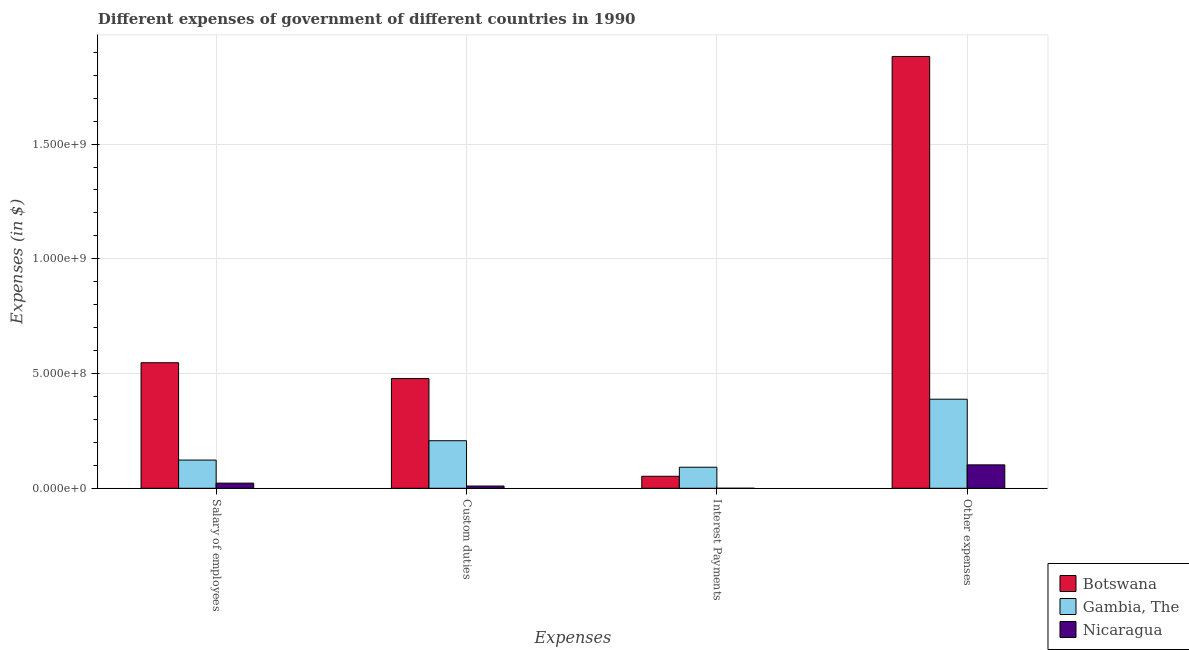How many different coloured bars are there?
Make the answer very short. 3. How many groups of bars are there?
Your response must be concise. 4. How many bars are there on the 1st tick from the left?
Provide a short and direct response. 3. What is the label of the 4th group of bars from the left?
Your answer should be compact. Other expenses. What is the amount spent on interest payments in Gambia, The?
Offer a very short reply. 9.17e+07. Across all countries, what is the maximum amount spent on salary of employees?
Give a very brief answer. 5.47e+08. Across all countries, what is the minimum amount spent on interest payments?
Keep it short and to the point. 8000. In which country was the amount spent on salary of employees maximum?
Offer a very short reply. Botswana. In which country was the amount spent on other expenses minimum?
Give a very brief answer. Nicaragua. What is the total amount spent on other expenses in the graph?
Ensure brevity in your answer.  2.37e+09. What is the difference between the amount spent on interest payments in Botswana and that in Nicaragua?
Your response must be concise. 5.23e+07. What is the difference between the amount spent on salary of employees in Nicaragua and the amount spent on interest payments in Botswana?
Offer a terse response. -2.99e+07. What is the average amount spent on other expenses per country?
Your response must be concise. 7.91e+08. What is the difference between the amount spent on salary of employees and amount spent on interest payments in Botswana?
Your answer should be very brief. 4.95e+08. What is the ratio of the amount spent on salary of employees in Nicaragua to that in Gambia, The?
Provide a short and direct response. 0.18. Is the difference between the amount spent on other expenses in Botswana and Nicaragua greater than the difference between the amount spent on custom duties in Botswana and Nicaragua?
Your answer should be very brief. Yes. What is the difference between the highest and the second highest amount spent on other expenses?
Make the answer very short. 1.49e+09. What is the difference between the highest and the lowest amount spent on custom duties?
Ensure brevity in your answer.  4.68e+08. In how many countries, is the amount spent on other expenses greater than the average amount spent on other expenses taken over all countries?
Your answer should be compact. 1. Is it the case that in every country, the sum of the amount spent on interest payments and amount spent on custom duties is greater than the sum of amount spent on other expenses and amount spent on salary of employees?
Give a very brief answer. No. What does the 1st bar from the left in Other expenses represents?
Offer a terse response. Botswana. What does the 3rd bar from the right in Other expenses represents?
Make the answer very short. Botswana. Is it the case that in every country, the sum of the amount spent on salary of employees and amount spent on custom duties is greater than the amount spent on interest payments?
Keep it short and to the point. Yes. Are all the bars in the graph horizontal?
Keep it short and to the point. No. What is the difference between two consecutive major ticks on the Y-axis?
Your response must be concise. 5.00e+08. Does the graph contain grids?
Your answer should be compact. Yes. How are the legend labels stacked?
Your answer should be very brief. Vertical. What is the title of the graph?
Provide a succinct answer. Different expenses of government of different countries in 1990. Does "East Asia (all income levels)" appear as one of the legend labels in the graph?
Your answer should be very brief. No. What is the label or title of the X-axis?
Offer a terse response. Expenses. What is the label or title of the Y-axis?
Provide a short and direct response. Expenses (in $). What is the Expenses (in $) in Botswana in Salary of employees?
Your answer should be very brief. 5.47e+08. What is the Expenses (in $) in Gambia, The in Salary of employees?
Ensure brevity in your answer.  1.23e+08. What is the Expenses (in $) in Nicaragua in Salary of employees?
Keep it short and to the point. 2.24e+07. What is the Expenses (in $) of Botswana in Custom duties?
Make the answer very short. 4.78e+08. What is the Expenses (in $) in Gambia, The in Custom duties?
Give a very brief answer. 2.07e+08. What is the Expenses (in $) of Nicaragua in Custom duties?
Your answer should be compact. 9.75e+06. What is the Expenses (in $) of Botswana in Interest Payments?
Offer a very short reply. 5.23e+07. What is the Expenses (in $) of Gambia, The in Interest Payments?
Your response must be concise. 9.17e+07. What is the Expenses (in $) of Nicaragua in Interest Payments?
Offer a terse response. 8000. What is the Expenses (in $) of Botswana in Other expenses?
Make the answer very short. 1.88e+09. What is the Expenses (in $) in Gambia, The in Other expenses?
Keep it short and to the point. 3.88e+08. What is the Expenses (in $) in Nicaragua in Other expenses?
Keep it short and to the point. 1.02e+08. Across all Expenses, what is the maximum Expenses (in $) of Botswana?
Make the answer very short. 1.88e+09. Across all Expenses, what is the maximum Expenses (in $) of Gambia, The?
Give a very brief answer. 3.88e+08. Across all Expenses, what is the maximum Expenses (in $) in Nicaragua?
Give a very brief answer. 1.02e+08. Across all Expenses, what is the minimum Expenses (in $) in Botswana?
Give a very brief answer. 5.23e+07. Across all Expenses, what is the minimum Expenses (in $) in Gambia, The?
Your answer should be very brief. 9.17e+07. Across all Expenses, what is the minimum Expenses (in $) of Nicaragua?
Offer a very short reply. 8000. What is the total Expenses (in $) in Botswana in the graph?
Make the answer very short. 2.96e+09. What is the total Expenses (in $) in Gambia, The in the graph?
Provide a short and direct response. 8.10e+08. What is the total Expenses (in $) in Nicaragua in the graph?
Offer a very short reply. 1.34e+08. What is the difference between the Expenses (in $) in Botswana in Salary of employees and that in Custom duties?
Provide a short and direct response. 6.89e+07. What is the difference between the Expenses (in $) of Gambia, The in Salary of employees and that in Custom duties?
Your answer should be compact. -8.43e+07. What is the difference between the Expenses (in $) of Nicaragua in Salary of employees and that in Custom duties?
Your response must be concise. 1.27e+07. What is the difference between the Expenses (in $) in Botswana in Salary of employees and that in Interest Payments?
Your answer should be compact. 4.95e+08. What is the difference between the Expenses (in $) in Gambia, The in Salary of employees and that in Interest Payments?
Make the answer very short. 3.12e+07. What is the difference between the Expenses (in $) in Nicaragua in Salary of employees and that in Interest Payments?
Your response must be concise. 2.24e+07. What is the difference between the Expenses (in $) in Botswana in Salary of employees and that in Other expenses?
Make the answer very short. -1.33e+09. What is the difference between the Expenses (in $) in Gambia, The in Salary of employees and that in Other expenses?
Your answer should be very brief. -2.65e+08. What is the difference between the Expenses (in $) in Nicaragua in Salary of employees and that in Other expenses?
Offer a terse response. -7.96e+07. What is the difference between the Expenses (in $) in Botswana in Custom duties and that in Interest Payments?
Provide a succinct answer. 4.26e+08. What is the difference between the Expenses (in $) in Gambia, The in Custom duties and that in Interest Payments?
Keep it short and to the point. 1.16e+08. What is the difference between the Expenses (in $) of Nicaragua in Custom duties and that in Interest Payments?
Keep it short and to the point. 9.74e+06. What is the difference between the Expenses (in $) of Botswana in Custom duties and that in Other expenses?
Provide a succinct answer. -1.40e+09. What is the difference between the Expenses (in $) of Gambia, The in Custom duties and that in Other expenses?
Provide a succinct answer. -1.81e+08. What is the difference between the Expenses (in $) in Nicaragua in Custom duties and that in Other expenses?
Offer a terse response. -9.23e+07. What is the difference between the Expenses (in $) in Botswana in Interest Payments and that in Other expenses?
Keep it short and to the point. -1.83e+09. What is the difference between the Expenses (in $) in Gambia, The in Interest Payments and that in Other expenses?
Give a very brief answer. -2.96e+08. What is the difference between the Expenses (in $) of Nicaragua in Interest Payments and that in Other expenses?
Give a very brief answer. -1.02e+08. What is the difference between the Expenses (in $) of Botswana in Salary of employees and the Expenses (in $) of Gambia, The in Custom duties?
Ensure brevity in your answer.  3.40e+08. What is the difference between the Expenses (in $) of Botswana in Salary of employees and the Expenses (in $) of Nicaragua in Custom duties?
Keep it short and to the point. 5.37e+08. What is the difference between the Expenses (in $) in Gambia, The in Salary of employees and the Expenses (in $) in Nicaragua in Custom duties?
Provide a short and direct response. 1.13e+08. What is the difference between the Expenses (in $) in Botswana in Salary of employees and the Expenses (in $) in Gambia, The in Interest Payments?
Provide a short and direct response. 4.55e+08. What is the difference between the Expenses (in $) in Botswana in Salary of employees and the Expenses (in $) in Nicaragua in Interest Payments?
Keep it short and to the point. 5.47e+08. What is the difference between the Expenses (in $) of Gambia, The in Salary of employees and the Expenses (in $) of Nicaragua in Interest Payments?
Offer a terse response. 1.23e+08. What is the difference between the Expenses (in $) in Botswana in Salary of employees and the Expenses (in $) in Gambia, The in Other expenses?
Provide a succinct answer. 1.59e+08. What is the difference between the Expenses (in $) in Botswana in Salary of employees and the Expenses (in $) in Nicaragua in Other expenses?
Your response must be concise. 4.45e+08. What is the difference between the Expenses (in $) in Gambia, The in Salary of employees and the Expenses (in $) in Nicaragua in Other expenses?
Make the answer very short. 2.09e+07. What is the difference between the Expenses (in $) of Botswana in Custom duties and the Expenses (in $) of Gambia, The in Interest Payments?
Provide a succinct answer. 3.86e+08. What is the difference between the Expenses (in $) of Botswana in Custom duties and the Expenses (in $) of Nicaragua in Interest Payments?
Keep it short and to the point. 4.78e+08. What is the difference between the Expenses (in $) of Gambia, The in Custom duties and the Expenses (in $) of Nicaragua in Interest Payments?
Offer a terse response. 2.07e+08. What is the difference between the Expenses (in $) of Botswana in Custom duties and the Expenses (in $) of Gambia, The in Other expenses?
Your answer should be very brief. 9.00e+07. What is the difference between the Expenses (in $) of Botswana in Custom duties and the Expenses (in $) of Nicaragua in Other expenses?
Make the answer very short. 3.76e+08. What is the difference between the Expenses (in $) of Gambia, The in Custom duties and the Expenses (in $) of Nicaragua in Other expenses?
Offer a very short reply. 1.05e+08. What is the difference between the Expenses (in $) of Botswana in Interest Payments and the Expenses (in $) of Gambia, The in Other expenses?
Give a very brief answer. -3.36e+08. What is the difference between the Expenses (in $) of Botswana in Interest Payments and the Expenses (in $) of Nicaragua in Other expenses?
Your answer should be compact. -4.97e+07. What is the difference between the Expenses (in $) in Gambia, The in Interest Payments and the Expenses (in $) in Nicaragua in Other expenses?
Your answer should be very brief. -1.03e+07. What is the average Expenses (in $) in Botswana per Expenses?
Make the answer very short. 7.40e+08. What is the average Expenses (in $) of Gambia, The per Expenses?
Keep it short and to the point. 2.03e+08. What is the average Expenses (in $) in Nicaragua per Expenses?
Make the answer very short. 3.36e+07. What is the difference between the Expenses (in $) of Botswana and Expenses (in $) of Gambia, The in Salary of employees?
Your answer should be compact. 4.24e+08. What is the difference between the Expenses (in $) in Botswana and Expenses (in $) in Nicaragua in Salary of employees?
Your answer should be compact. 5.25e+08. What is the difference between the Expenses (in $) in Gambia, The and Expenses (in $) in Nicaragua in Salary of employees?
Make the answer very short. 1.00e+08. What is the difference between the Expenses (in $) in Botswana and Expenses (in $) in Gambia, The in Custom duties?
Offer a terse response. 2.71e+08. What is the difference between the Expenses (in $) of Botswana and Expenses (in $) of Nicaragua in Custom duties?
Offer a very short reply. 4.68e+08. What is the difference between the Expenses (in $) in Gambia, The and Expenses (in $) in Nicaragua in Custom duties?
Provide a succinct answer. 1.97e+08. What is the difference between the Expenses (in $) of Botswana and Expenses (in $) of Gambia, The in Interest Payments?
Offer a terse response. -3.94e+07. What is the difference between the Expenses (in $) of Botswana and Expenses (in $) of Nicaragua in Interest Payments?
Keep it short and to the point. 5.23e+07. What is the difference between the Expenses (in $) in Gambia, The and Expenses (in $) in Nicaragua in Interest Payments?
Your response must be concise. 9.17e+07. What is the difference between the Expenses (in $) of Botswana and Expenses (in $) of Gambia, The in Other expenses?
Your answer should be very brief. 1.49e+09. What is the difference between the Expenses (in $) in Botswana and Expenses (in $) in Nicaragua in Other expenses?
Your response must be concise. 1.78e+09. What is the difference between the Expenses (in $) in Gambia, The and Expenses (in $) in Nicaragua in Other expenses?
Your response must be concise. 2.86e+08. What is the ratio of the Expenses (in $) in Botswana in Salary of employees to that in Custom duties?
Give a very brief answer. 1.14. What is the ratio of the Expenses (in $) in Gambia, The in Salary of employees to that in Custom duties?
Give a very brief answer. 0.59. What is the ratio of the Expenses (in $) in Nicaragua in Salary of employees to that in Custom duties?
Give a very brief answer. 2.3. What is the ratio of the Expenses (in $) in Botswana in Salary of employees to that in Interest Payments?
Ensure brevity in your answer.  10.46. What is the ratio of the Expenses (in $) of Gambia, The in Salary of employees to that in Interest Payments?
Provide a short and direct response. 1.34. What is the ratio of the Expenses (in $) of Nicaragua in Salary of employees to that in Interest Payments?
Keep it short and to the point. 2806.25. What is the ratio of the Expenses (in $) in Botswana in Salary of employees to that in Other expenses?
Give a very brief answer. 0.29. What is the ratio of the Expenses (in $) of Gambia, The in Salary of employees to that in Other expenses?
Offer a terse response. 0.32. What is the ratio of the Expenses (in $) in Nicaragua in Salary of employees to that in Other expenses?
Provide a short and direct response. 0.22. What is the ratio of the Expenses (in $) of Botswana in Custom duties to that in Interest Payments?
Offer a very short reply. 9.14. What is the ratio of the Expenses (in $) in Gambia, The in Custom duties to that in Interest Payments?
Provide a succinct answer. 2.26. What is the ratio of the Expenses (in $) in Nicaragua in Custom duties to that in Interest Payments?
Offer a very short reply. 1218.75. What is the ratio of the Expenses (in $) of Botswana in Custom duties to that in Other expenses?
Provide a short and direct response. 0.25. What is the ratio of the Expenses (in $) of Gambia, The in Custom duties to that in Other expenses?
Provide a succinct answer. 0.53. What is the ratio of the Expenses (in $) in Nicaragua in Custom duties to that in Other expenses?
Your answer should be very brief. 0.1. What is the ratio of the Expenses (in $) of Botswana in Interest Payments to that in Other expenses?
Your answer should be compact. 0.03. What is the ratio of the Expenses (in $) in Gambia, The in Interest Payments to that in Other expenses?
Keep it short and to the point. 0.24. What is the ratio of the Expenses (in $) of Nicaragua in Interest Payments to that in Other expenses?
Your answer should be compact. 0. What is the difference between the highest and the second highest Expenses (in $) of Botswana?
Your response must be concise. 1.33e+09. What is the difference between the highest and the second highest Expenses (in $) of Gambia, The?
Provide a short and direct response. 1.81e+08. What is the difference between the highest and the second highest Expenses (in $) of Nicaragua?
Ensure brevity in your answer.  7.96e+07. What is the difference between the highest and the lowest Expenses (in $) in Botswana?
Ensure brevity in your answer.  1.83e+09. What is the difference between the highest and the lowest Expenses (in $) in Gambia, The?
Keep it short and to the point. 2.96e+08. What is the difference between the highest and the lowest Expenses (in $) of Nicaragua?
Provide a succinct answer. 1.02e+08. 